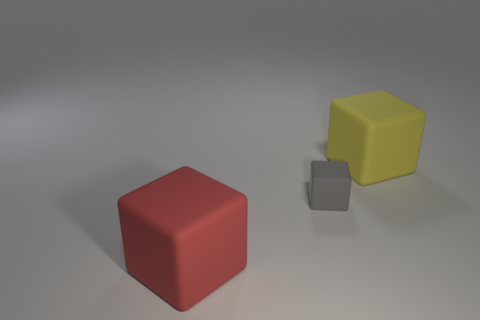Are there any other things that have the same size as the gray thing?
Your answer should be very brief. No. What is the color of the tiny object that is the same material as the big yellow object?
Your answer should be compact. Gray. Are there an equal number of large yellow blocks that are to the left of the tiny gray matte thing and small red rubber spheres?
Offer a terse response. Yes. What is the shape of the matte thing that is the same size as the red matte cube?
Your response must be concise. Cube. How many other things are there of the same shape as the large red object?
Offer a very short reply. 2. There is a red matte object; is it the same size as the object that is behind the tiny rubber cube?
Offer a terse response. Yes. How many things are either tiny gray things right of the large red thing or big objects?
Provide a short and direct response. 3. What shape is the large rubber object that is right of the big red object?
Your answer should be very brief. Cube. Is the number of big things that are on the right side of the big red matte cube the same as the number of gray things that are to the right of the gray matte block?
Provide a short and direct response. No. There is a large red cube that is in front of the big thing that is behind the big red matte block; what is it made of?
Your answer should be very brief. Rubber. 